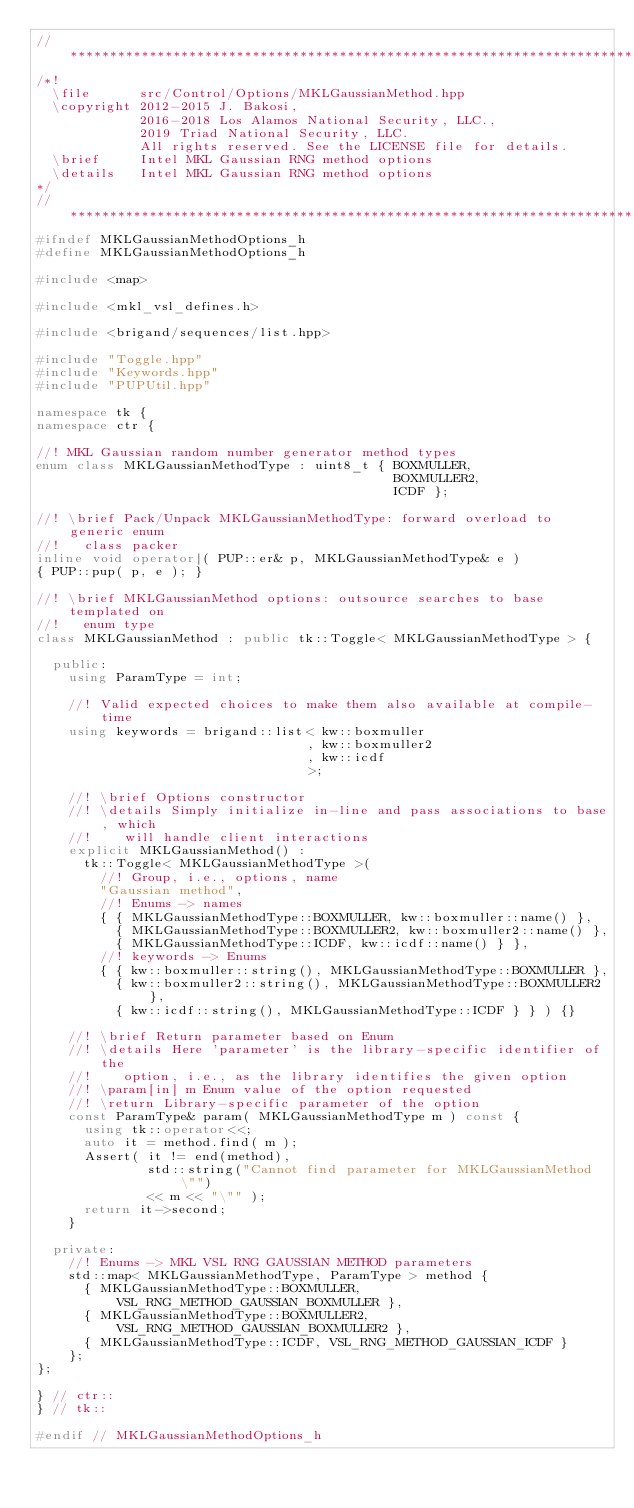Convert code to text. <code><loc_0><loc_0><loc_500><loc_500><_C++_>// *****************************************************************************
/*!
  \file      src/Control/Options/MKLGaussianMethod.hpp
  \copyright 2012-2015 J. Bakosi,
             2016-2018 Los Alamos National Security, LLC.,
             2019 Triad National Security, LLC.
             All rights reserved. See the LICENSE file for details.
  \brief     Intel MKL Gaussian RNG method options
  \details   Intel MKL Gaussian RNG method options
*/
// *****************************************************************************
#ifndef MKLGaussianMethodOptions_h
#define MKLGaussianMethodOptions_h

#include <map>

#include <mkl_vsl_defines.h>

#include <brigand/sequences/list.hpp>

#include "Toggle.hpp"
#include "Keywords.hpp"
#include "PUPUtil.hpp"

namespace tk {
namespace ctr {

//! MKL Gaussian random number generator method types
enum class MKLGaussianMethodType : uint8_t { BOXMULLER,
                                             BOXMULLER2,
                                             ICDF };

//! \brief Pack/Unpack MKLGaussianMethodType: forward overload to generic enum
//!   class packer
inline void operator|( PUP::er& p, MKLGaussianMethodType& e )
{ PUP::pup( p, e ); }

//! \brief MKLGaussianMethod options: outsource searches to base templated on
//!   enum type
class MKLGaussianMethod : public tk::Toggle< MKLGaussianMethodType > {

  public:
    using ParamType = int;

    //! Valid expected choices to make them also available at compile-time
    using keywords = brigand::list< kw::boxmuller
                                  , kw::boxmuller2
                                  , kw::icdf
                                  >;

    //! \brief Options constructor
    //! \details Simply initialize in-line and pass associations to base, which
    //!    will handle client interactions
    explicit MKLGaussianMethod() :
      tk::Toggle< MKLGaussianMethodType >(
        //! Group, i.e., options, name
        "Gaussian method",
        //! Enums -> names
        { { MKLGaussianMethodType::BOXMULLER, kw::boxmuller::name() },
          { MKLGaussianMethodType::BOXMULLER2, kw::boxmuller2::name() },
          { MKLGaussianMethodType::ICDF, kw::icdf::name() } },
        //! keywords -> Enums
        { { kw::boxmuller::string(), MKLGaussianMethodType::BOXMULLER },
          { kw::boxmuller2::string(), MKLGaussianMethodType::BOXMULLER2 },
          { kw::icdf::string(), MKLGaussianMethodType::ICDF } } ) {}

    //! \brief Return parameter based on Enum
    //! \details Here 'parameter' is the library-specific identifier of the
    //!    option, i.e., as the library identifies the given option
    //! \param[in] m Enum value of the option requested
    //! \return Library-specific parameter of the option
    const ParamType& param( MKLGaussianMethodType m ) const {
      using tk::operator<<;
      auto it = method.find( m );
      Assert( it != end(method),
              std::string("Cannot find parameter for MKLGaussianMethod \"")
              << m << "\"" );
      return it->second;
    }

  private:
    //! Enums -> MKL VSL RNG GAUSSIAN METHOD parameters
    std::map< MKLGaussianMethodType, ParamType > method {
      { MKLGaussianMethodType::BOXMULLER, VSL_RNG_METHOD_GAUSSIAN_BOXMULLER },
      { MKLGaussianMethodType::BOXMULLER2, VSL_RNG_METHOD_GAUSSIAN_BOXMULLER2 },
      { MKLGaussianMethodType::ICDF, VSL_RNG_METHOD_GAUSSIAN_ICDF }
    };
};

} // ctr::
} // tk::

#endif // MKLGaussianMethodOptions_h
</code> 